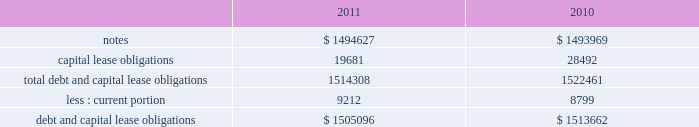Note 17 .
Debt our debt as of december 2 , 2011 and december 3 , 2010 consisted of the following ( in thousands ) : capital lease obligations total debt and capital lease obligations less : current portion debt and capital lease obligations $ 1494627 19681 1514308 $ 1505096 $ 1493969 28492 1522461 $ 1513662 in february 2010 , we issued $ 600.0 million of 3.25% ( 3.25 % ) senior notes due february 1 , 2015 ( the 201c2015 notes 201d ) and $ 900.0 million of 4.75% ( 4.75 % ) senior notes due february 1 , 2020 ( the 201c2020 notes 201d and , together with the 2015 notes , the 201cnotes 201d ) .
Our proceeds were approximately $ 1.5 billion and were net of an issuance discount of $ 6.6 million .
The notes rank equally with our other unsecured and unsubordinated indebtedness .
In addition , we incurred issuance costs of approximately $ 10.7 million .
Both the discount and issuance costs are being amortized to interest expense over the respective terms of the notes using the effective interest method .
The effective interest rate including the discount and issuance costs is 3.45% ( 3.45 % ) for the 2015 notes and 4.92% ( 4.92 % ) for the 2020 notes .
Interest is payable semi-annually , in arrears , on february 1 and august 1 , commencing on august 1 , 2010 .
During fiscal 2011 interest payments totaled $ 62.3 million .
The proceeds from the notes are available for general corporate purposes , including repayment of any balance outstanding on our credit facility .
Based on quoted market prices , the fair value of the notes was approximately $ 1.6 billion as of december 2 , 2011 .
We may redeem the notes at any time , subject to a make whole premium .
In addition , upon the occurrence of certain change of control triggering events , we may be required to repurchase the notes , at a price equal to 101% ( 101 % ) of their principal amount , plus accrued and unpaid interest to the date of repurchase .
The notes also include covenants that limit our ability to grant liens on assets and to enter into sale and leaseback transactions , subject to significant allowances .
As of december 2 , 2011 , we were in compliance with all of the covenants .
Credit agreement in august 2007 , we entered into an amendment to our credit agreement dated february 2007 ( the 201camendment 201d ) , which increased the total senior unsecured revolving facility from $ 500.0 million to $ 1.0 billion .
The amendment also permits us to request one-year extensions effective on each anniversary of the closing date of the original agreement , subject to the majority consent of the lenders .
We also retain an option to request an additional $ 500.0 million in commitments , for a maximum aggregate facility of $ 1.5 billion .
In february 2008 , we entered into a second amendment to the credit agreement dated february 26 , 2008 , which extended the maturity date of the facility by one year to february 16 , 2013 .
The facility would terminate at this date if no additional extensions have been requested and granted .
All other terms and conditions remain the same .
The facility contains a financial covenant requiring us not to exceed a certain maximum leverage ratio .
At our option , borrowings under the facility accrue interest based on either the london interbank offered rate ( 201clibor 201d ) for one , two , three or six months , or longer periods with bank consent , plus a margin according to a pricing grid tied to this financial covenant , or a base rate .
The margin is set at rates between 0.20% ( 0.20 % ) and 0.475% ( 0.475 % ) .
Commitment fees are payable on the facility at rates between 0.05% ( 0.05 % ) and 0.15% ( 0.15 % ) per year based on the same pricing grid .
The facility is available to provide loans to us and certain of our subsidiaries for general corporate purposes .
On february 1 , 2010 , we paid the outstanding balance on our credit facility and the entire $ 1.0 billion credit line under this facility remains available for borrowing .
Capital lease obligation in june 2010 , we entered into a sale-leaseback agreement to sell equipment totaling $ 32.2 million and leaseback the same equipment over a period of 43 months .
This transaction was classified as a capital lease obligation and recorded at fair value .
As of december 2 , 2011 , our capital lease obligations of $ 19.7 million includes $ 9.2 million of current debt .
Table of contents adobe systems incorporated notes to consolidated financial statements ( continued ) .
Note 17 .
Debt our debt as of december 2 , 2011 and december 3 , 2010 consisted of the following ( in thousands ) : capital lease obligations total debt and capital lease obligations less : current portion debt and capital lease obligations $ 1494627 19681 1514308 $ 1505096 $ 1493969 28492 1522461 $ 1513662 in february 2010 , we issued $ 600.0 million of 3.25% ( 3.25 % ) senior notes due february 1 , 2015 ( the 201c2015 notes 201d ) and $ 900.0 million of 4.75% ( 4.75 % ) senior notes due february 1 , 2020 ( the 201c2020 notes 201d and , together with the 2015 notes , the 201cnotes 201d ) .
Our proceeds were approximately $ 1.5 billion and were net of an issuance discount of $ 6.6 million .
The notes rank equally with our other unsecured and unsubordinated indebtedness .
In addition , we incurred issuance costs of approximately $ 10.7 million .
Both the discount and issuance costs are being amortized to interest expense over the respective terms of the notes using the effective interest method .
The effective interest rate including the discount and issuance costs is 3.45% ( 3.45 % ) for the 2015 notes and 4.92% ( 4.92 % ) for the 2020 notes .
Interest is payable semi-annually , in arrears , on february 1 and august 1 , commencing on august 1 , 2010 .
During fiscal 2011 interest payments totaled $ 62.3 million .
The proceeds from the notes are available for general corporate purposes , including repayment of any balance outstanding on our credit facility .
Based on quoted market prices , the fair value of the notes was approximately $ 1.6 billion as of december 2 , 2011 .
We may redeem the notes at any time , subject to a make whole premium .
In addition , upon the occurrence of certain change of control triggering events , we may be required to repurchase the notes , at a price equal to 101% ( 101 % ) of their principal amount , plus accrued and unpaid interest to the date of repurchase .
The notes also include covenants that limit our ability to grant liens on assets and to enter into sale and leaseback transactions , subject to significant allowances .
As of december 2 , 2011 , we were in compliance with all of the covenants .
Credit agreement in august 2007 , we entered into an amendment to our credit agreement dated february 2007 ( the 201camendment 201d ) , which increased the total senior unsecured revolving facility from $ 500.0 million to $ 1.0 billion .
The amendment also permits us to request one-year extensions effective on each anniversary of the closing date of the original agreement , subject to the majority consent of the lenders .
We also retain an option to request an additional $ 500.0 million in commitments , for a maximum aggregate facility of $ 1.5 billion .
In february 2008 , we entered into a second amendment to the credit agreement dated february 26 , 2008 , which extended the maturity date of the facility by one year to february 16 , 2013 .
The facility would terminate at this date if no additional extensions have been requested and granted .
All other terms and conditions remain the same .
The facility contains a financial covenant requiring us not to exceed a certain maximum leverage ratio .
At our option , borrowings under the facility accrue interest based on either the london interbank offered rate ( 201clibor 201d ) for one , two , three or six months , or longer periods with bank consent , plus a margin according to a pricing grid tied to this financial covenant , or a base rate .
The margin is set at rates between 0.20% ( 0.20 % ) and 0.475% ( 0.475 % ) .
Commitment fees are payable on the facility at rates between 0.05% ( 0.05 % ) and 0.15% ( 0.15 % ) per year based on the same pricing grid .
The facility is available to provide loans to us and certain of our subsidiaries for general corporate purposes .
On february 1 , 2010 , we paid the outstanding balance on our credit facility and the entire $ 1.0 billion credit line under this facility remains available for borrowing .
Capital lease obligation in june 2010 , we entered into a sale-leaseback agreement to sell equipment totaling $ 32.2 million and leaseback the same equipment over a period of 43 months .
This transaction was classified as a capital lease obligation and recorded at fair value .
As of december 2 , 2011 , our capital lease obligations of $ 19.7 million includes $ 9.2 million of current debt .
Table of contents adobe systems incorporated notes to consolidated financial statements ( continued ) .
What is the growth rate in the balance of total debt and capital lease obligations in 2011? 
Computations: ((1514308 - 1522461) / 1522461)
Answer: -0.00536. 